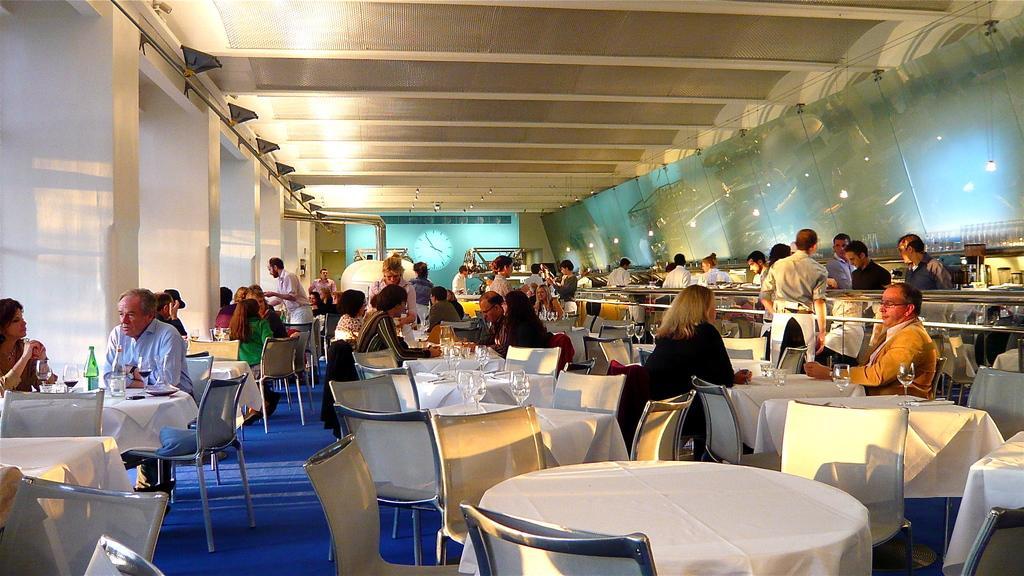Describe this image in one or two sentences. In this image,There are lot of tables which are covered by a white color cloth, There are some people sitting on the chairs, In the right side of the image there is a glass, In the top of the image is a roof of cream color, And in the left of the image there is a glass of white colors. 